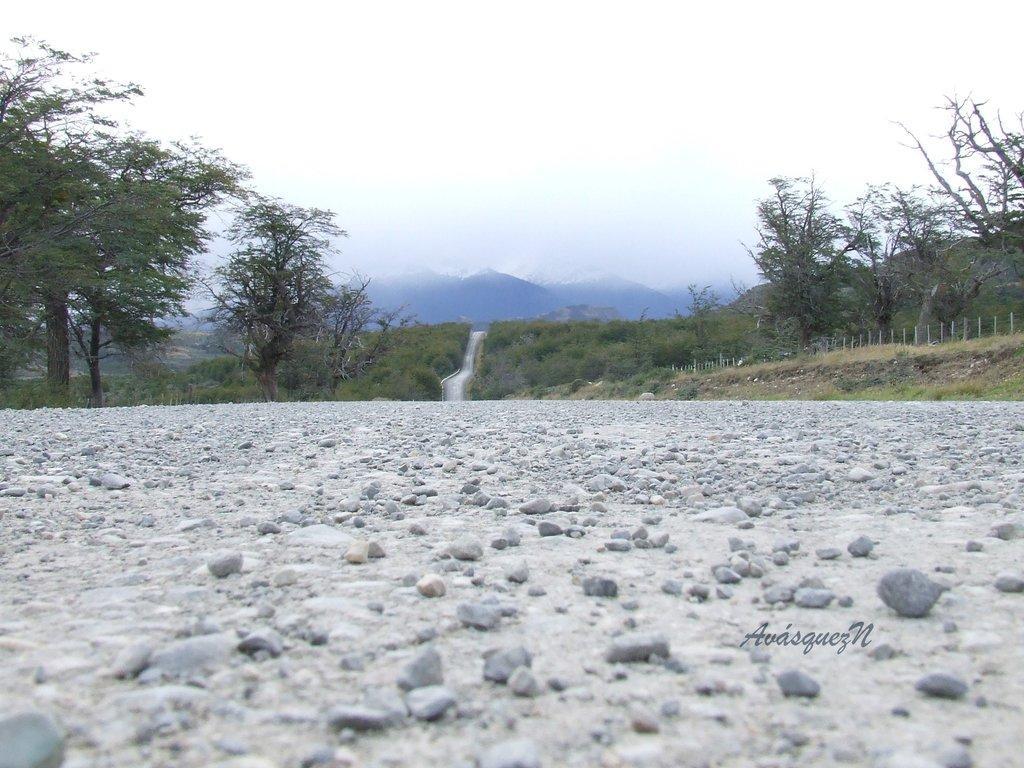What natural feature is the main subject of the image? There is a waterfall in the image. What can be seen in the distance behind the waterfall? There are hills and trees in the background of the image. What is covering the ground at the bottom of the image? The ground at the bottom of the image is covered with stones. How much mist is present around the waterfall in the image? There is no mention of mist in the image, so it cannot be determined how much mist is present. 